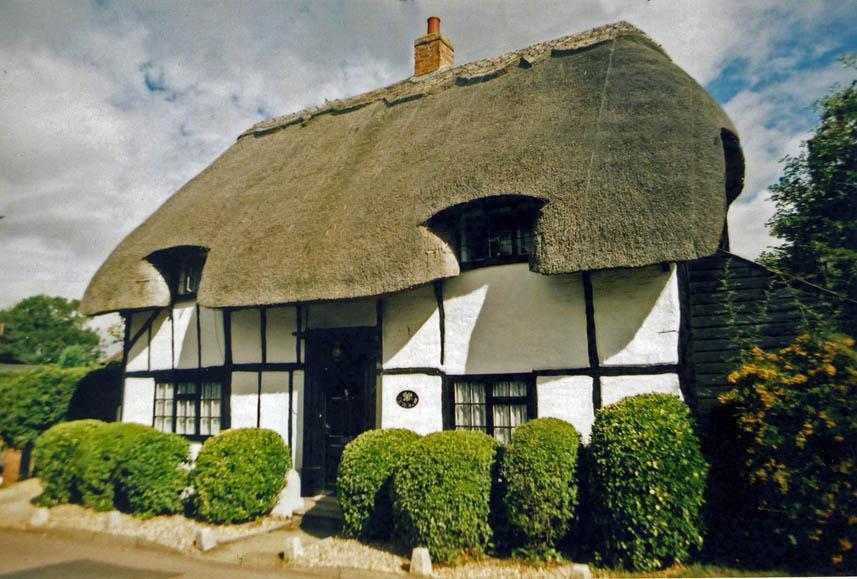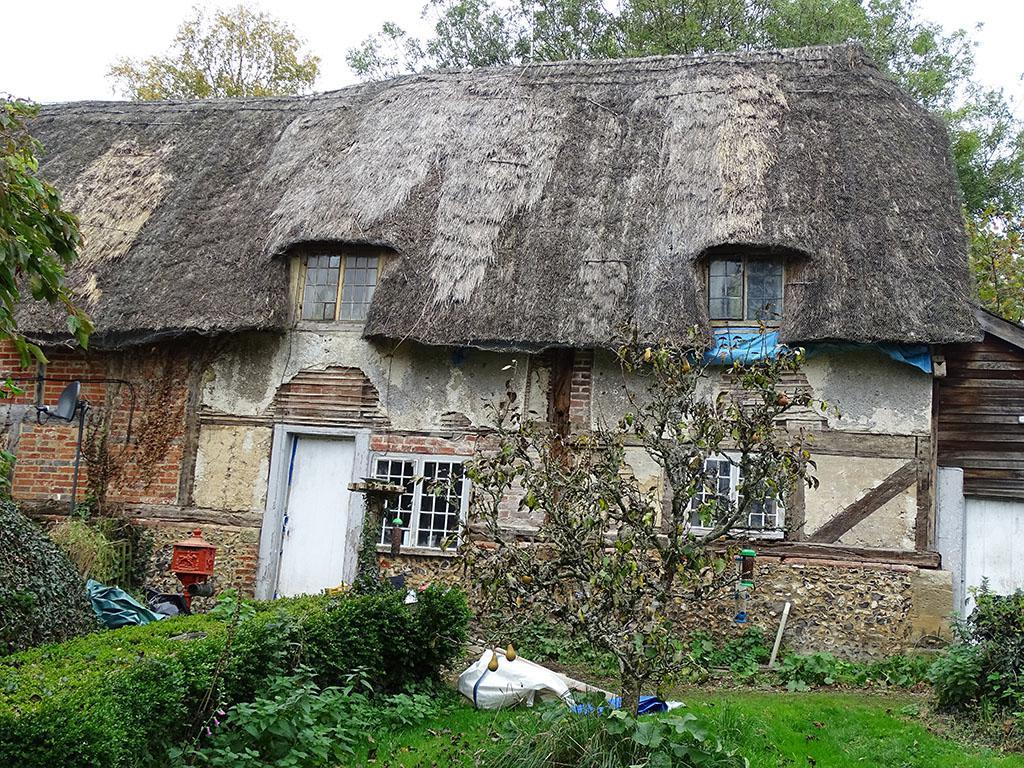The first image is the image on the left, the second image is the image on the right. Analyze the images presented: Is the assertion "There is a house with a thatch roof with two dormered windows, the home has a dark colored door and black lines on the front of the home" valid? Answer yes or no. Yes. The first image is the image on the left, the second image is the image on the right. Evaluate the accuracy of this statement regarding the images: "In at least one image there is a house with exposed wood planks about a white front door.". Is it true? Answer yes or no. Yes. 